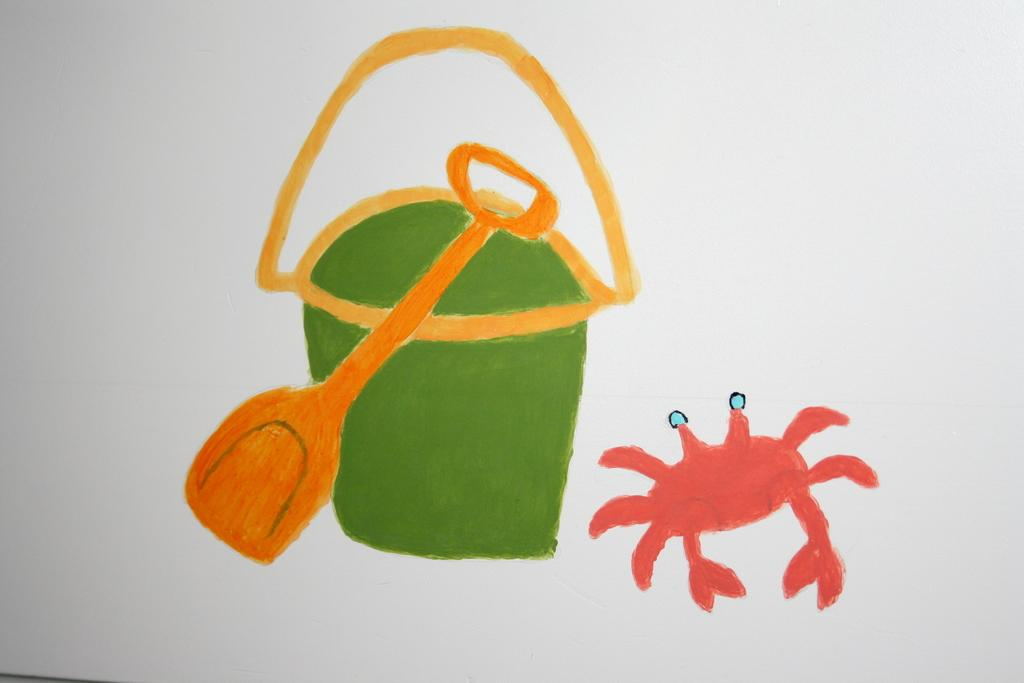What is the main subject of the painting in the image? The painting features a crab. Are there any objects present in the painting? Yes, the painting includes a shovel and a bucket. What is the color of the background in the painting? The background of the painting is white. What type of seashore can be seen in the painting? There is no seashore present in the painting; it features a crab, a shovel, and a bucket against a white background. What kind of apparatus is used by the crab to taste the sand in the painting? The painting does not depict the crab tasting the sand, nor does it show any apparatus for that purpose. 